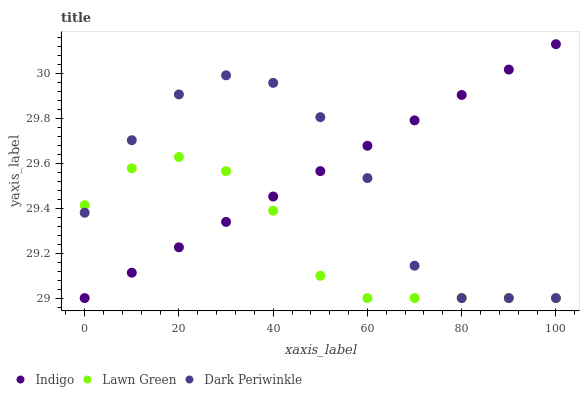Does Lawn Green have the minimum area under the curve?
Answer yes or no. Yes. Does Indigo have the maximum area under the curve?
Answer yes or no. Yes. Does Dark Periwinkle have the minimum area under the curve?
Answer yes or no. No. Does Dark Periwinkle have the maximum area under the curve?
Answer yes or no. No. Is Indigo the smoothest?
Answer yes or no. Yes. Is Dark Periwinkle the roughest?
Answer yes or no. Yes. Is Dark Periwinkle the smoothest?
Answer yes or no. No. Is Indigo the roughest?
Answer yes or no. No. Does Lawn Green have the lowest value?
Answer yes or no. Yes. Does Indigo have the highest value?
Answer yes or no. Yes. Does Dark Periwinkle have the highest value?
Answer yes or no. No. Does Lawn Green intersect Dark Periwinkle?
Answer yes or no. Yes. Is Lawn Green less than Dark Periwinkle?
Answer yes or no. No. Is Lawn Green greater than Dark Periwinkle?
Answer yes or no. No. 